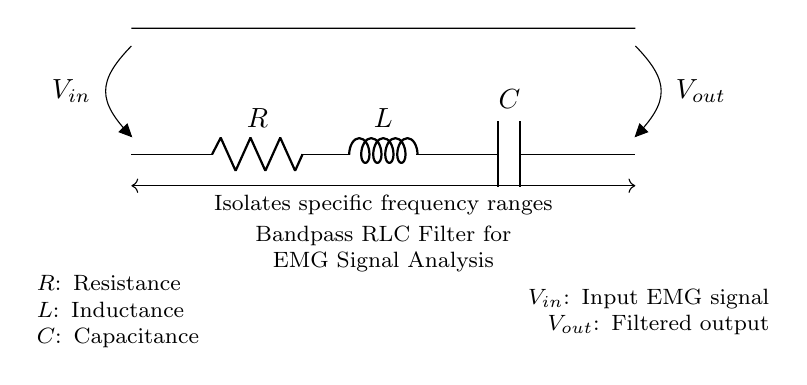What is the type of filter represented in the circuit? The circuit diagram depicts a bandpass filter, indicated by the arrangement of the resistor, inductor, and capacitor designed to isolate specific frequency ranges.
Answer: Bandpass filter What are the components of this circuit? The components shown in the circuit diagram are a resistor, an inductor, and a capacitor, which together form a bandpass RLC filter.
Answer: Resistor, inductor, capacitor What does the input voltage represent? The input voltage, labeled as V in, represents the EMG signal that is being analyzed and filtered through the circuit.
Answer: Input EMG signal What is the output voltage labeled as? The output voltage is labeled as V out, representing the filtered signal resulting from the bandpass RLC filter action on the input signal.
Answer: Filtered output What does this circuit isolate? The circuit is designed to isolate specific frequency ranges from the input signal, as indicated by the annotation connecting the input and output.
Answer: Specific frequency ranges Why is a bandpass filter used in EMG signal analysis? A bandpass filter is utilized to allow only specific frequency components of the EMG signal to pass through, which is crucial for analyzing muscle activity during athletic movements while filtering out noise.
Answer: To allow specific frequency components to pass 